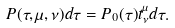Convert formula to latex. <formula><loc_0><loc_0><loc_500><loc_500>P ( \tau , \mu , \nu ) d \tau = P _ { 0 } ( \tau ) t ^ { \mu } _ { \nu } d \tau .</formula> 